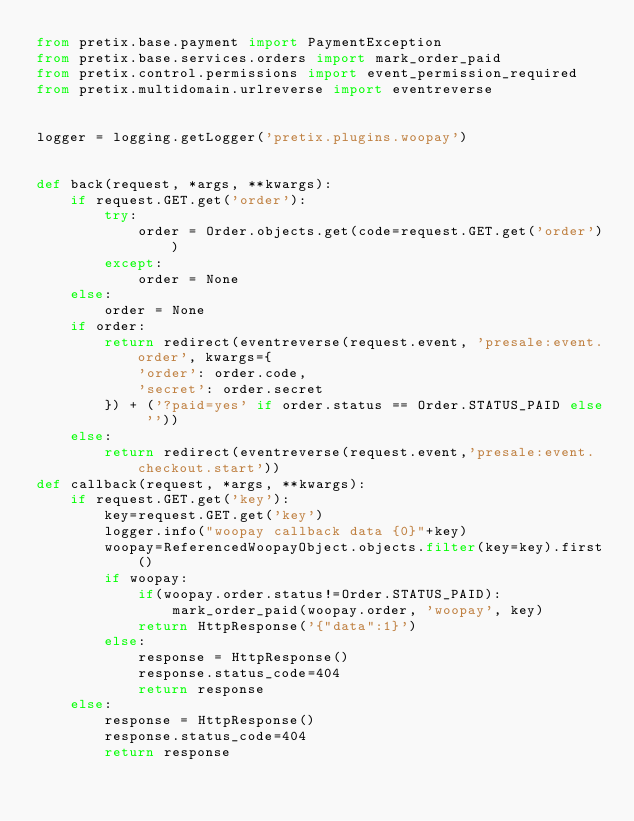Convert code to text. <code><loc_0><loc_0><loc_500><loc_500><_Python_>from pretix.base.payment import PaymentException
from pretix.base.services.orders import mark_order_paid
from pretix.control.permissions import event_permission_required
from pretix.multidomain.urlreverse import eventreverse


logger = logging.getLogger('pretix.plugins.woopay')


def back(request, *args, **kwargs):
    if request.GET.get('order'):
        try:
            order = Order.objects.get(code=request.GET.get('order'))
        except:
            order = None
    else:
        order = None
    if order:
        return redirect(eventreverse(request.event, 'presale:event.order', kwargs={
            'order': order.code,
            'secret': order.secret
        }) + ('?paid=yes' if order.status == Order.STATUS_PAID else ''))
    else:
        return redirect(eventreverse(request.event,'presale:event.checkout.start'))
def callback(request, *args, **kwargs):
    if request.GET.get('key'):
        key=request.GET.get('key')
        logger.info("woopay callback data {0}"+key)
        woopay=ReferencedWoopayObject.objects.filter(key=key).first()
        if woopay:
            if(woopay.order.status!=Order.STATUS_PAID):
                mark_order_paid(woopay.order, 'woopay', key)
            return HttpResponse('{"data":1}')
        else:
            response = HttpResponse()
            response.status_code=404
            return response
    else:
        response = HttpResponse()
        response.status_code=404
        return response</code> 